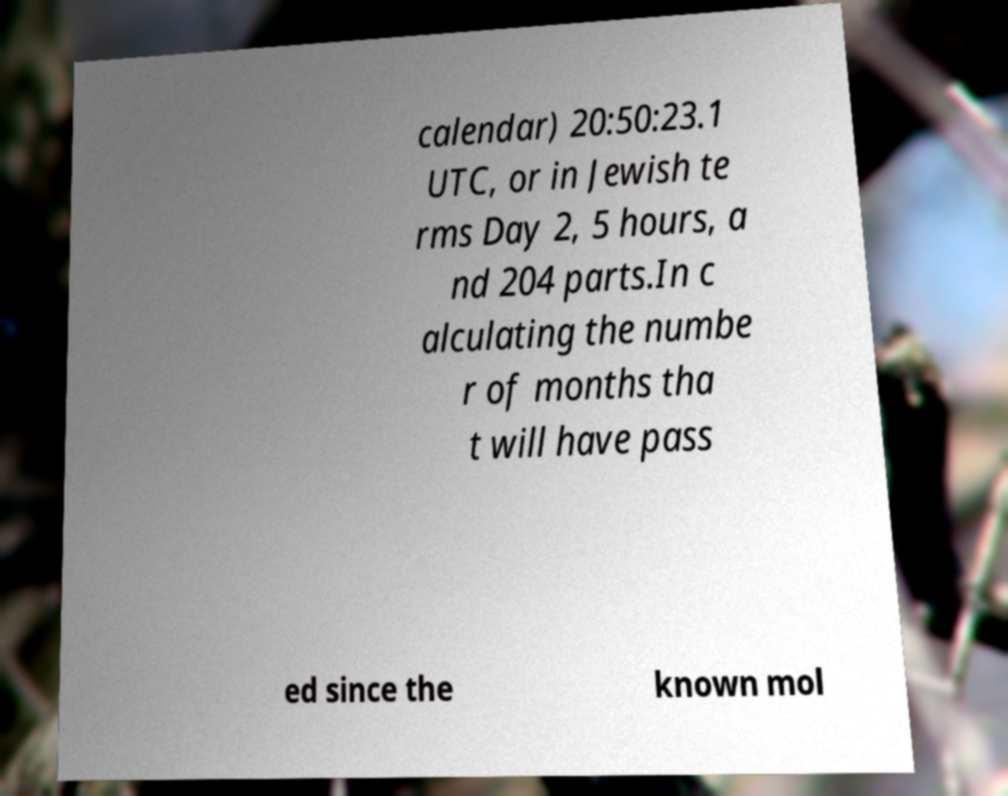Please identify and transcribe the text found in this image. calendar) 20:50:23.1 UTC, or in Jewish te rms Day 2, 5 hours, a nd 204 parts.In c alculating the numbe r of months tha t will have pass ed since the known mol 